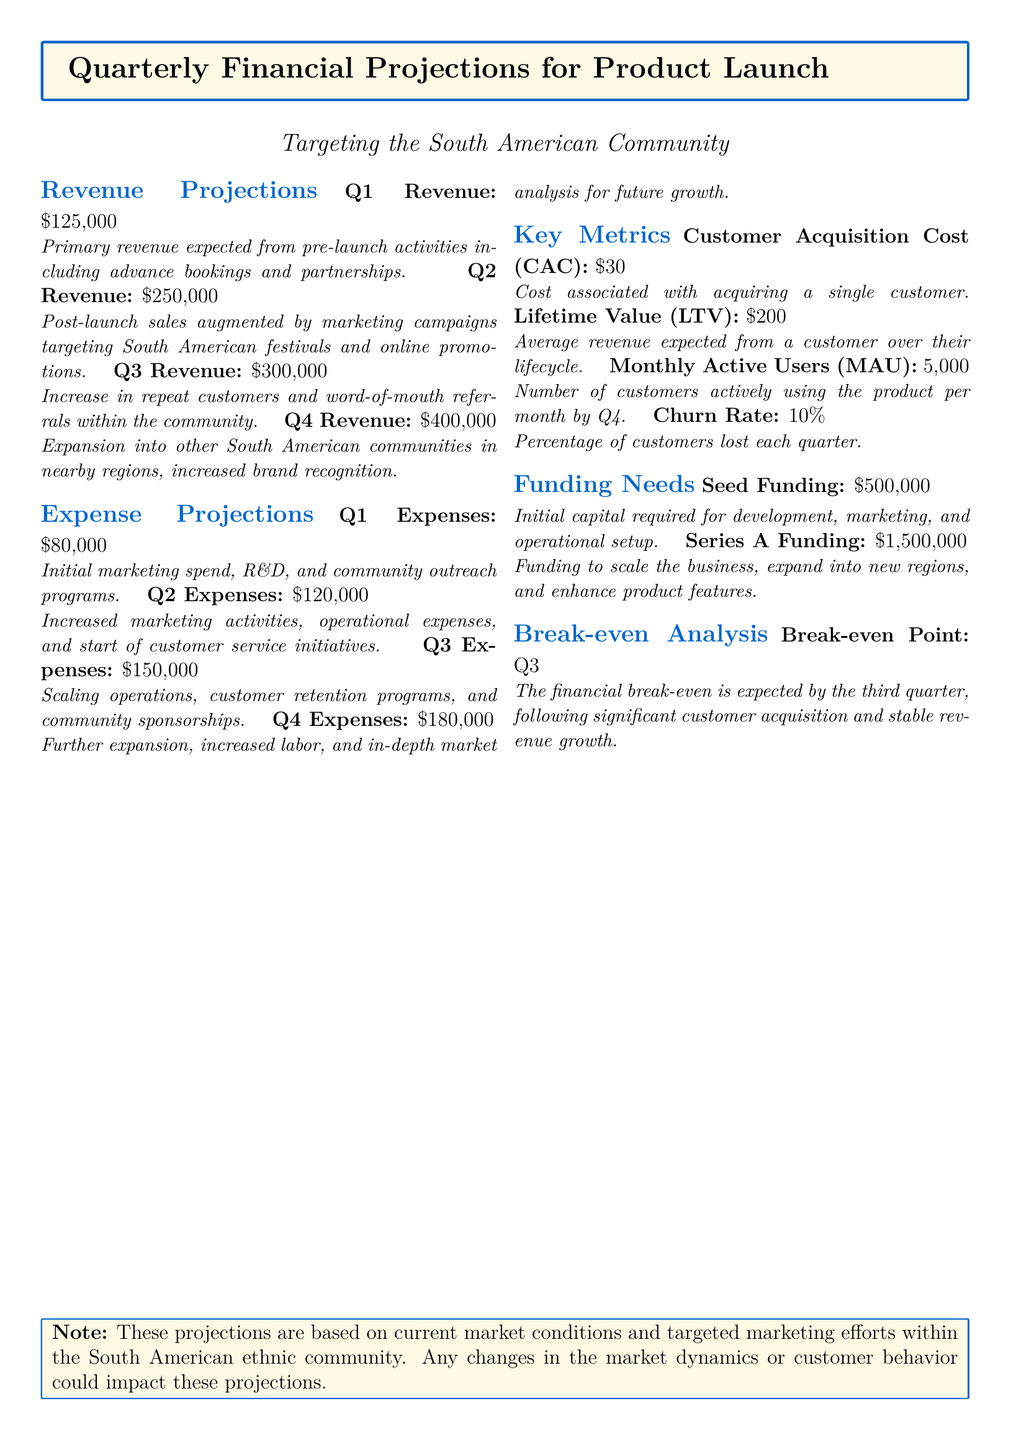What is the expected Q1 revenue? The expected Q1 revenue is explicitly mentioned in the document under Revenue Projections.
Answer: $125,000 What is the main focus for Q2 marketing efforts? The document states that marketing campaigns will target South American festivals and online promotions for Q2.
Answer: South American festivals and online promotions What is the projected Q4 expense? The Q4 expense is specified in the Expense Projections section of the document.
Answer: $180,000 What is the average Lifetime Value (LTV) of a customer? The LTV is noted in the Key Metrics section and represents revenue from a customer over their lifecycle.
Answer: $200 Which quarter is expected to reach the break-even point? This information is outlined in the Break-even Analysis section of the document.
Answer: Q3 What is the monthly active user target by Q4? The target for Monthly Active Users is mentioned in the Key Metrics section.
Answer: 5,000 How much seed funding is required? The funding needs are detailed in the Funding Needs section of the document.
Answer: $500,000 What is the Customer Acquisition Cost (CAC)? The CAC is provided in the Key Metrics section and indicates customer acquisition expense.
Answer: $30 